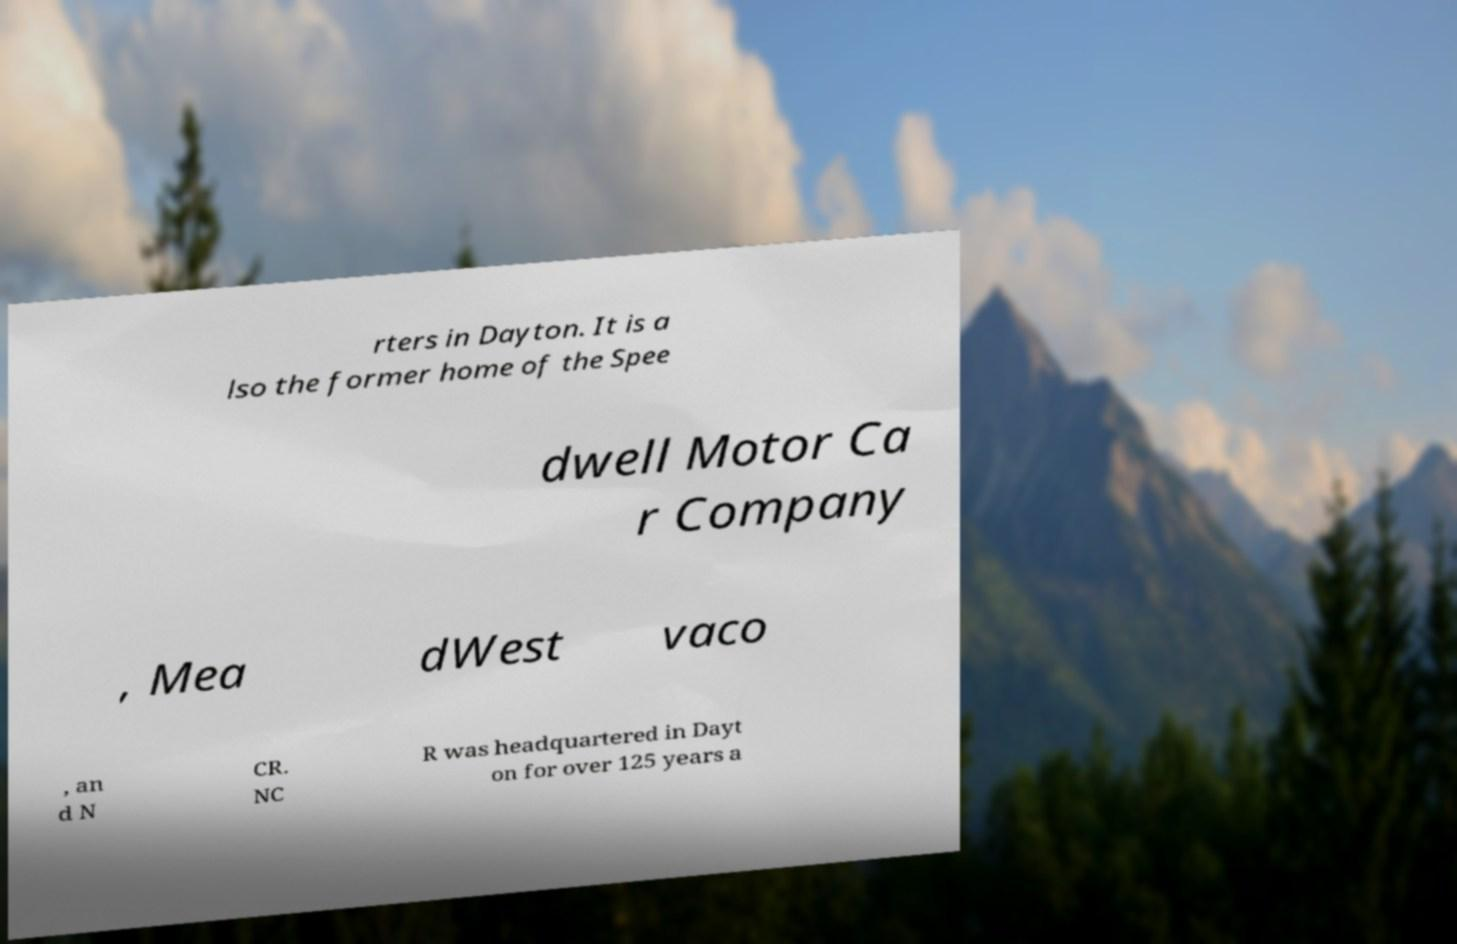For documentation purposes, I need the text within this image transcribed. Could you provide that? rters in Dayton. It is a lso the former home of the Spee dwell Motor Ca r Company , Mea dWest vaco , an d N CR. NC R was headquartered in Dayt on for over 125 years a 